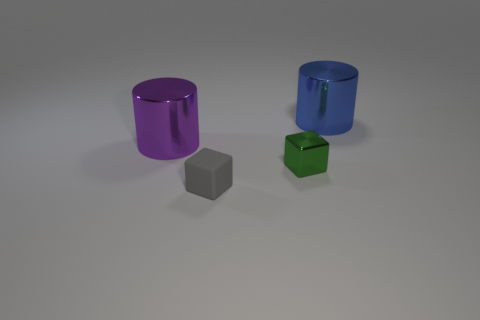Subtract all red cylinders. Subtract all purple balls. How many cylinders are left? 2 Add 2 large cyan rubber cubes. How many objects exist? 6 Add 4 green objects. How many green objects exist? 5 Subtract 0 purple spheres. How many objects are left? 4 Subtract all big blue shiny things. Subtract all large blue cylinders. How many objects are left? 2 Add 1 matte objects. How many matte objects are left? 2 